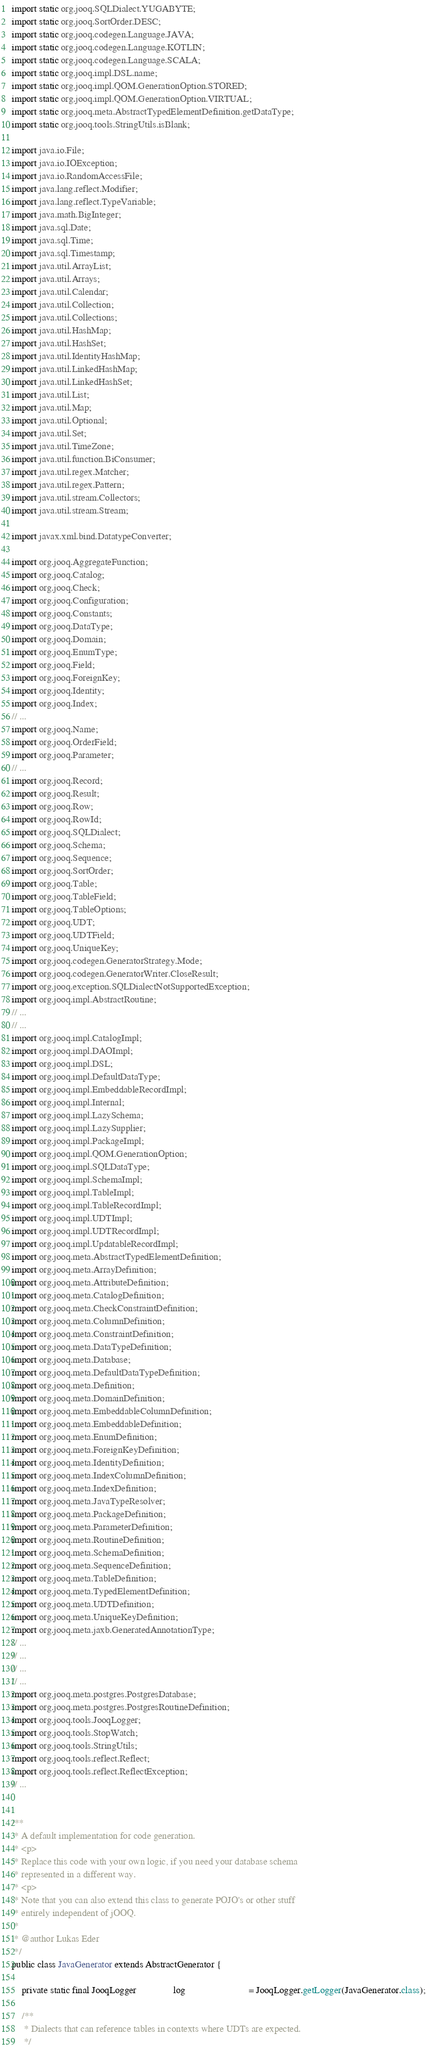Convert code to text. <code><loc_0><loc_0><loc_500><loc_500><_Java_>import static org.jooq.SQLDialect.YUGABYTE;
import static org.jooq.SortOrder.DESC;
import static org.jooq.codegen.Language.JAVA;
import static org.jooq.codegen.Language.KOTLIN;
import static org.jooq.codegen.Language.SCALA;
import static org.jooq.impl.DSL.name;
import static org.jooq.impl.QOM.GenerationOption.STORED;
import static org.jooq.impl.QOM.GenerationOption.VIRTUAL;
import static org.jooq.meta.AbstractTypedElementDefinition.getDataType;
import static org.jooq.tools.StringUtils.isBlank;

import java.io.File;
import java.io.IOException;
import java.io.RandomAccessFile;
import java.lang.reflect.Modifier;
import java.lang.reflect.TypeVariable;
import java.math.BigInteger;
import java.sql.Date;
import java.sql.Time;
import java.sql.Timestamp;
import java.util.ArrayList;
import java.util.Arrays;
import java.util.Calendar;
import java.util.Collection;
import java.util.Collections;
import java.util.HashMap;
import java.util.HashSet;
import java.util.IdentityHashMap;
import java.util.LinkedHashMap;
import java.util.LinkedHashSet;
import java.util.List;
import java.util.Map;
import java.util.Optional;
import java.util.Set;
import java.util.TimeZone;
import java.util.function.BiConsumer;
import java.util.regex.Matcher;
import java.util.regex.Pattern;
import java.util.stream.Collectors;
import java.util.stream.Stream;

import javax.xml.bind.DatatypeConverter;

import org.jooq.AggregateFunction;
import org.jooq.Catalog;
import org.jooq.Check;
import org.jooq.Configuration;
import org.jooq.Constants;
import org.jooq.DataType;
import org.jooq.Domain;
import org.jooq.EnumType;
import org.jooq.Field;
import org.jooq.ForeignKey;
import org.jooq.Identity;
import org.jooq.Index;
// ...
import org.jooq.Name;
import org.jooq.OrderField;
import org.jooq.Parameter;
// ...
import org.jooq.Record;
import org.jooq.Result;
import org.jooq.Row;
import org.jooq.RowId;
import org.jooq.SQLDialect;
import org.jooq.Schema;
import org.jooq.Sequence;
import org.jooq.SortOrder;
import org.jooq.Table;
import org.jooq.TableField;
import org.jooq.TableOptions;
import org.jooq.UDT;
import org.jooq.UDTField;
import org.jooq.UniqueKey;
import org.jooq.codegen.GeneratorStrategy.Mode;
import org.jooq.codegen.GeneratorWriter.CloseResult;
import org.jooq.exception.SQLDialectNotSupportedException;
import org.jooq.impl.AbstractRoutine;
// ...
// ...
import org.jooq.impl.CatalogImpl;
import org.jooq.impl.DAOImpl;
import org.jooq.impl.DSL;
import org.jooq.impl.DefaultDataType;
import org.jooq.impl.EmbeddableRecordImpl;
import org.jooq.impl.Internal;
import org.jooq.impl.LazySchema;
import org.jooq.impl.LazySupplier;
import org.jooq.impl.PackageImpl;
import org.jooq.impl.QOM.GenerationOption;
import org.jooq.impl.SQLDataType;
import org.jooq.impl.SchemaImpl;
import org.jooq.impl.TableImpl;
import org.jooq.impl.TableRecordImpl;
import org.jooq.impl.UDTImpl;
import org.jooq.impl.UDTRecordImpl;
import org.jooq.impl.UpdatableRecordImpl;
import org.jooq.meta.AbstractTypedElementDefinition;
import org.jooq.meta.ArrayDefinition;
import org.jooq.meta.AttributeDefinition;
import org.jooq.meta.CatalogDefinition;
import org.jooq.meta.CheckConstraintDefinition;
import org.jooq.meta.ColumnDefinition;
import org.jooq.meta.ConstraintDefinition;
import org.jooq.meta.DataTypeDefinition;
import org.jooq.meta.Database;
import org.jooq.meta.DefaultDataTypeDefinition;
import org.jooq.meta.Definition;
import org.jooq.meta.DomainDefinition;
import org.jooq.meta.EmbeddableColumnDefinition;
import org.jooq.meta.EmbeddableDefinition;
import org.jooq.meta.EnumDefinition;
import org.jooq.meta.ForeignKeyDefinition;
import org.jooq.meta.IdentityDefinition;
import org.jooq.meta.IndexColumnDefinition;
import org.jooq.meta.IndexDefinition;
import org.jooq.meta.JavaTypeResolver;
import org.jooq.meta.PackageDefinition;
import org.jooq.meta.ParameterDefinition;
import org.jooq.meta.RoutineDefinition;
import org.jooq.meta.SchemaDefinition;
import org.jooq.meta.SequenceDefinition;
import org.jooq.meta.TableDefinition;
import org.jooq.meta.TypedElementDefinition;
import org.jooq.meta.UDTDefinition;
import org.jooq.meta.UniqueKeyDefinition;
import org.jooq.meta.jaxb.GeneratedAnnotationType;
// ...
// ...
// ...
// ...
import org.jooq.meta.postgres.PostgresDatabase;
import org.jooq.meta.postgres.PostgresRoutineDefinition;
import org.jooq.tools.JooqLogger;
import org.jooq.tools.StopWatch;
import org.jooq.tools.StringUtils;
import org.jooq.tools.reflect.Reflect;
import org.jooq.tools.reflect.ReflectException;
// ...


/**
 * A default implementation for code generation.
 * <p>
 * Replace this code with your own logic, if you need your database schema
 * represented in a different way.
 * <p>
 * Note that you can also extend this class to generate POJO's or other stuff
 * entirely independent of jOOQ.
 *
 * @author Lukas Eder
 */
public class JavaGenerator extends AbstractGenerator {

    private static final JooqLogger               log                          = JooqLogger.getLogger(JavaGenerator.class);

    /**
     * Dialects that can reference tables in contexts where UDTs are expected.
     */</code> 